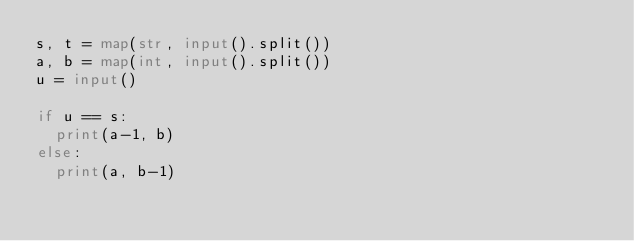Convert code to text. <code><loc_0><loc_0><loc_500><loc_500><_Python_>s, t = map(str, input().split())
a, b = map(int, input().split())
u = input()

if u == s:
  print(a-1, b)
else:
  print(a, b-1)</code> 